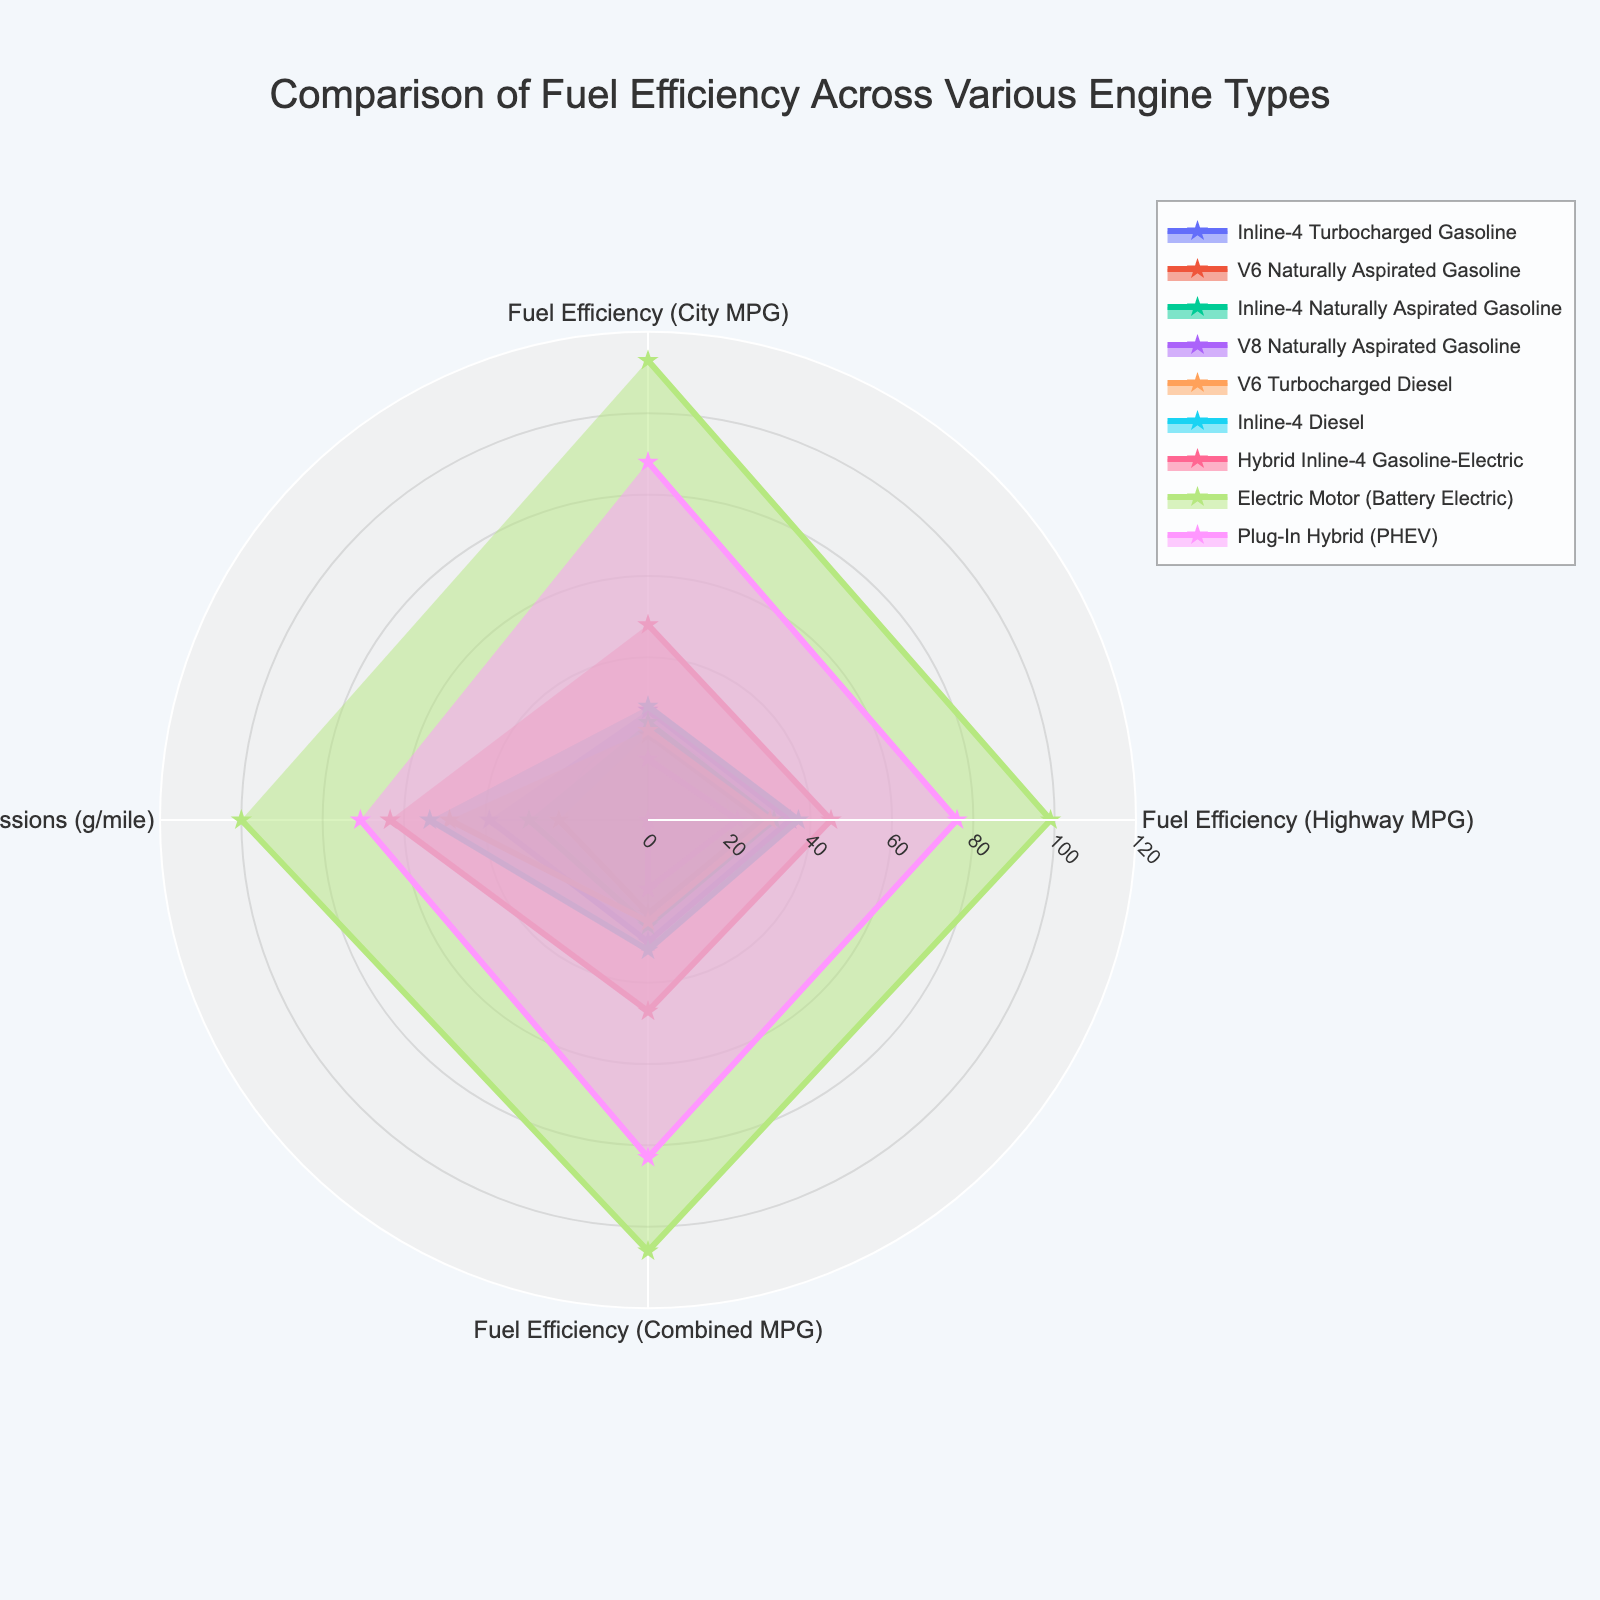What is the title of the radar chart? The title of the chart is displayed at the top center of the figure.
Answer: Comparison of Fuel Efficiency Across Various Engine Types Which engine type has the highest fuel efficiency in the city? By examining the City MPG values, the Electric Motor (Battery Electric) has the highest value.
Answer: Electric Motor (Battery Electric) Which engine type has the highest combined MPG value? By looking at the Combined MPG section, the Electric Motor (Battery Electric) has the highest value.
Answer: Electric Motor (Battery Electric) How are CO2 emissions represented on the chart? CO2 emissions are normalized and are shown as one of the categories in the radar chart, represented such that lower emissions have higher normalized values.
Answer: As normalized values Which engine type has the lowest CO2 emissions? By observing the normalized CO2 Emissions category, the Electric Motor (Battery Electric) has the highest normalized value, indicating the lowest raw emissions.
Answer: Electric Motor (Battery Electric) Which engine type has better highway fuel efficiency, the Inline-4 Turbocharged Gasoline or the V6 Naturally Aspirated Gasoline? Comparing the Highway MPG values, the Inline-4 Turbocharged Gasoline has a value of 35 MPG, whereas the V6 Naturally Aspirated Gasoline has 28 MPG.
Answer: Inline-4 Turbocharged Gasoline Besides the Electric Motor (Battery Electric), which engine type has the highest combined MPG? Excluding the highest values for Electric Motor (Battery Electric), the Plug-In Hybrid (PHEV) shows the highest combined MPG with 83 MPGe.
Answer: Plug-In Hybrid (PHEV) What is the general relationship between fuel efficiency and CO2 emissions shown in the chart? In the radar chart, higher fuel efficiency categories tend to have higher normalized CO2 emissions values, indicating lower raw CO2 emissions.
Answer: Higher fuel efficiency corresponds to lower CO2 emissions Which engine types demonstrate the best overall performance in terms of both fuel efficiency and CO2 emissions? Observing the radar chart, the Electric Motor (Battery Electric) and Hybrid Inline-4 Gasoline-Electric show high values for fuel efficiency and CO2 emissions, indicating superior performance overall.
Answer: Electric Motor (Battery Electric) and Hybrid Inline-4 Gasoline-Electric 